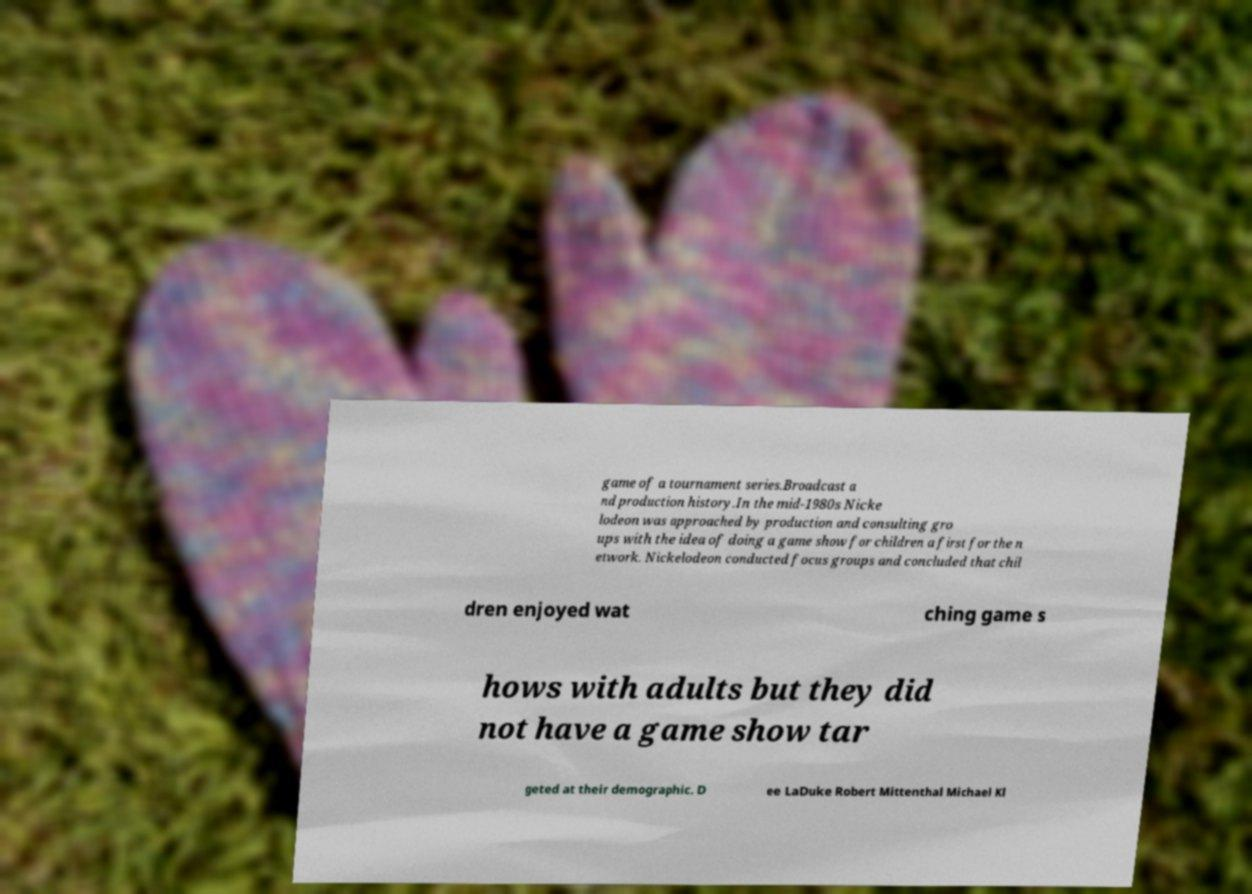Can you read and provide the text displayed in the image?This photo seems to have some interesting text. Can you extract and type it out for me? game of a tournament series.Broadcast a nd production history.In the mid-1980s Nicke lodeon was approached by production and consulting gro ups with the idea of doing a game show for children a first for the n etwork. Nickelodeon conducted focus groups and concluded that chil dren enjoyed wat ching game s hows with adults but they did not have a game show tar geted at their demographic. D ee LaDuke Robert Mittenthal Michael Kl 